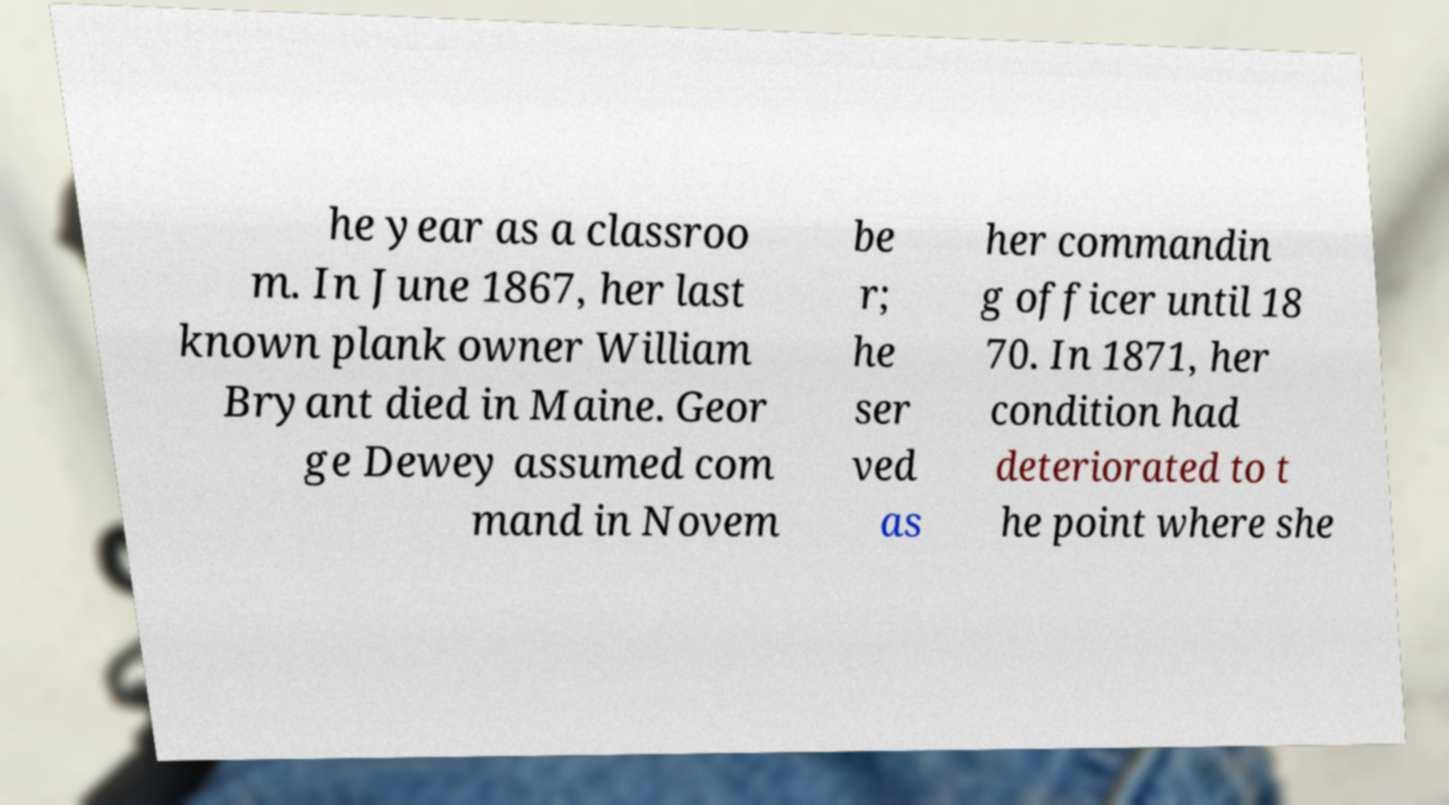There's text embedded in this image that I need extracted. Can you transcribe it verbatim? he year as a classroo m. In June 1867, her last known plank owner William Bryant died in Maine. Geor ge Dewey assumed com mand in Novem be r; he ser ved as her commandin g officer until 18 70. In 1871, her condition had deteriorated to t he point where she 